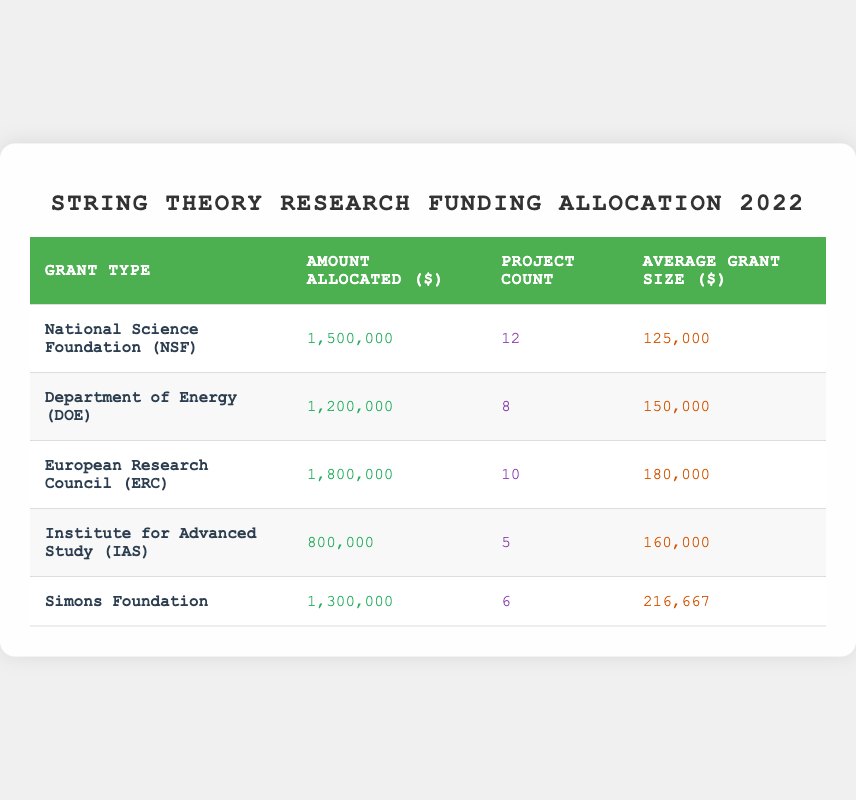What is the total amount allocated for string theory projects by the European Research Council? The amount allocated by the European Research Council is listed in the table as 1,800,000.
Answer: 1,800,000 Which grant type has the highest average grant size? The average grant sizes for each grant type are: NSF $125,000, DOE $150,000, ERC $180,000, IAS $160,000, and Simons Foundation $216,667. The Simons Foundation has the highest average grant size at $216,667.
Answer: Simons Foundation How much total funding was allocated by the NSF and the DOE combined? The total funding from NSF is 1,500,000 and from DOE is 1,200,000. Adding these amounts gives 1,500,000 + 1,200,000 = 2,700,000.
Answer: 2,700,000 Did the Institute for Advanced Study allocate more than 1 million dollars? The amount allocated by the Institute for Advanced Study is listed as 800,000, which is less than 1 million.
Answer: No What is the average grant size for all listed grant types? To find the average grant size, we first sum the average sizes: 125,000 (NSF) + 150,000 (DOE) + 180,000 (ERC) + 160,000 (IAS) + 216,667 (Simons) = 931,667. There are 5 grant types, so we divide: 931,667 / 5 = 186,333.4.
Answer: 186,333.4 